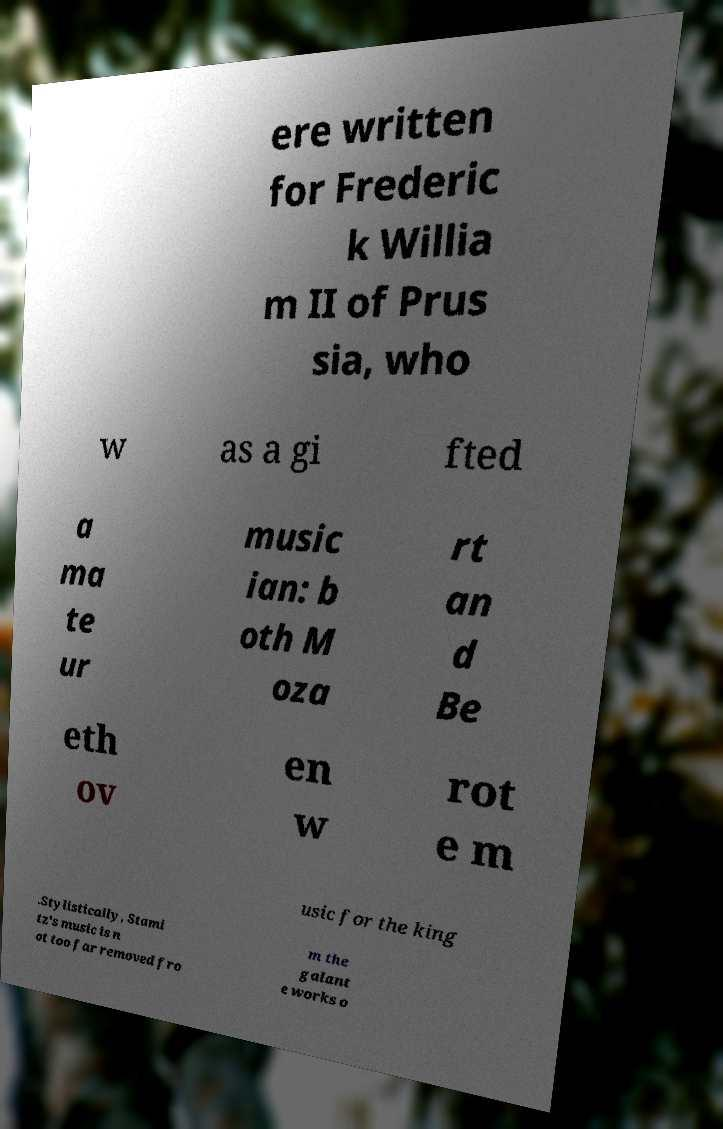There's text embedded in this image that I need extracted. Can you transcribe it verbatim? ere written for Frederic k Willia m II of Prus sia, who w as a gi fted a ma te ur music ian: b oth M oza rt an d Be eth ov en w rot e m usic for the king .Stylistically, Stami tz's music is n ot too far removed fro m the galant e works o 